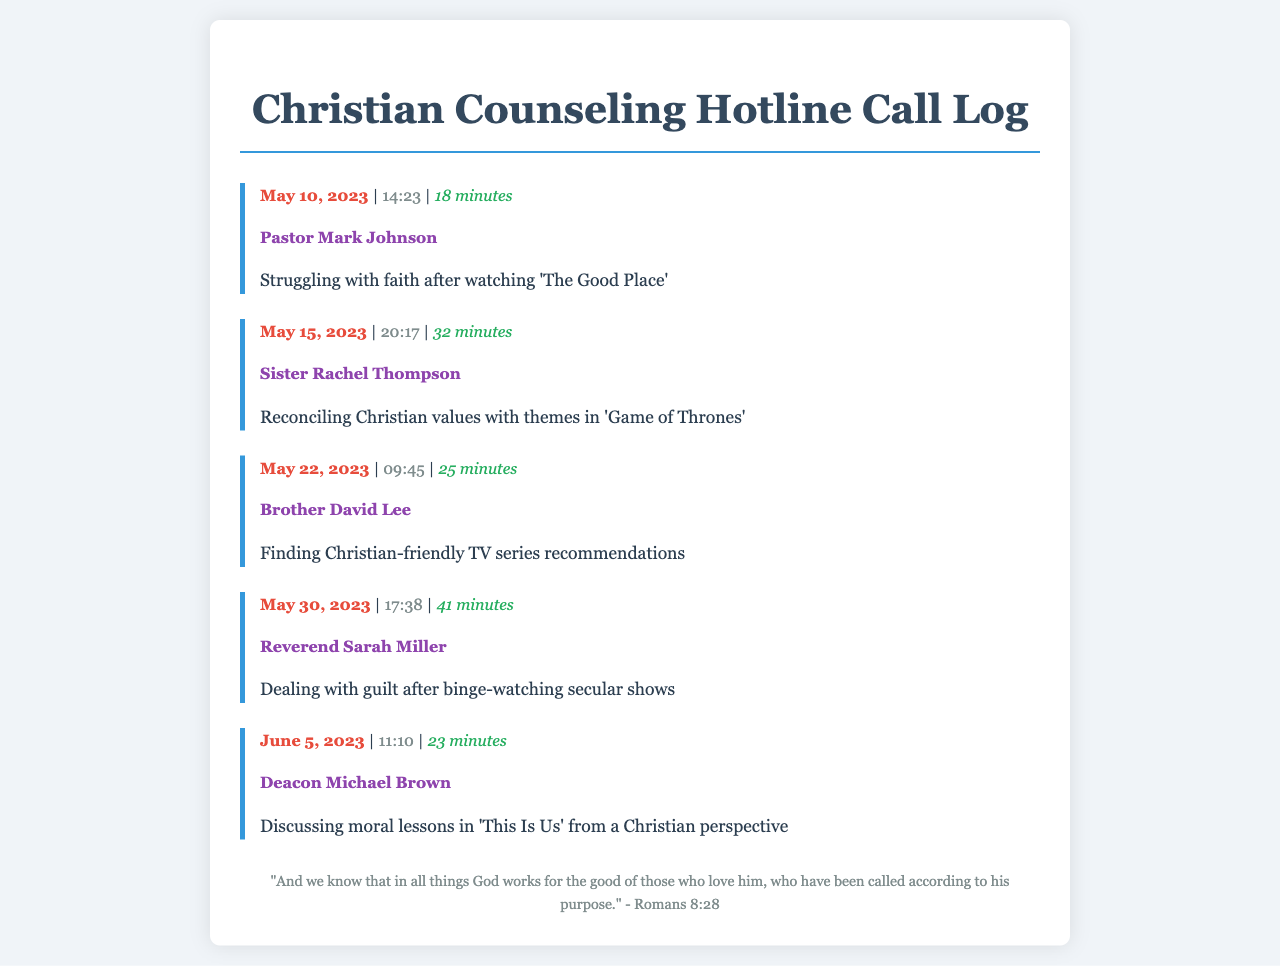What is the date of the first call? The first call is logged on May 10, 2023, making it the earliest date in the document.
Answer: May 10, 2023 Who was the counselor during the call on May 15, 2023? The call on this date was with Sister Rachel Thompson, which can be found directly under the date and time.
Answer: Sister Rachel Thompson How long was the call with Reverend Sarah Miller? The duration of the call with Reverend Sarah Miller is mentioned as 41 minutes, which is specified in the call log.
Answer: 41 minutes What topic was discussed during the call with Deacon Michael Brown? The topic discussed was the moral lessons in 'This Is Us' from a Christian perspective, which is stated under his name.
Answer: Discussing moral lessons in 'This Is Us' from a Christian perspective Which series was mentioned in relation to struggles with faith? The series that was referenced regarding struggles with faith is 'The Good Place,' noted in the first call log entry.
Answer: The Good Place What common theme can be inferred from the call topics? The topics revolve around the intersection of faith and popular culture, indicating a struggle with reconciling these aspects.
Answer: Intersection of faith and popular culture How many calls were made before June 1, 2023? There were four calls before this date, as listed in the call logs from May.
Answer: 4 calls Which counselor talked about guilt after binge-watching? The counselor discussing guilt after binge-watching was Reverend Sarah Miller, as noted in the May 30 entry.
Answer: Reverend Sarah Miller 